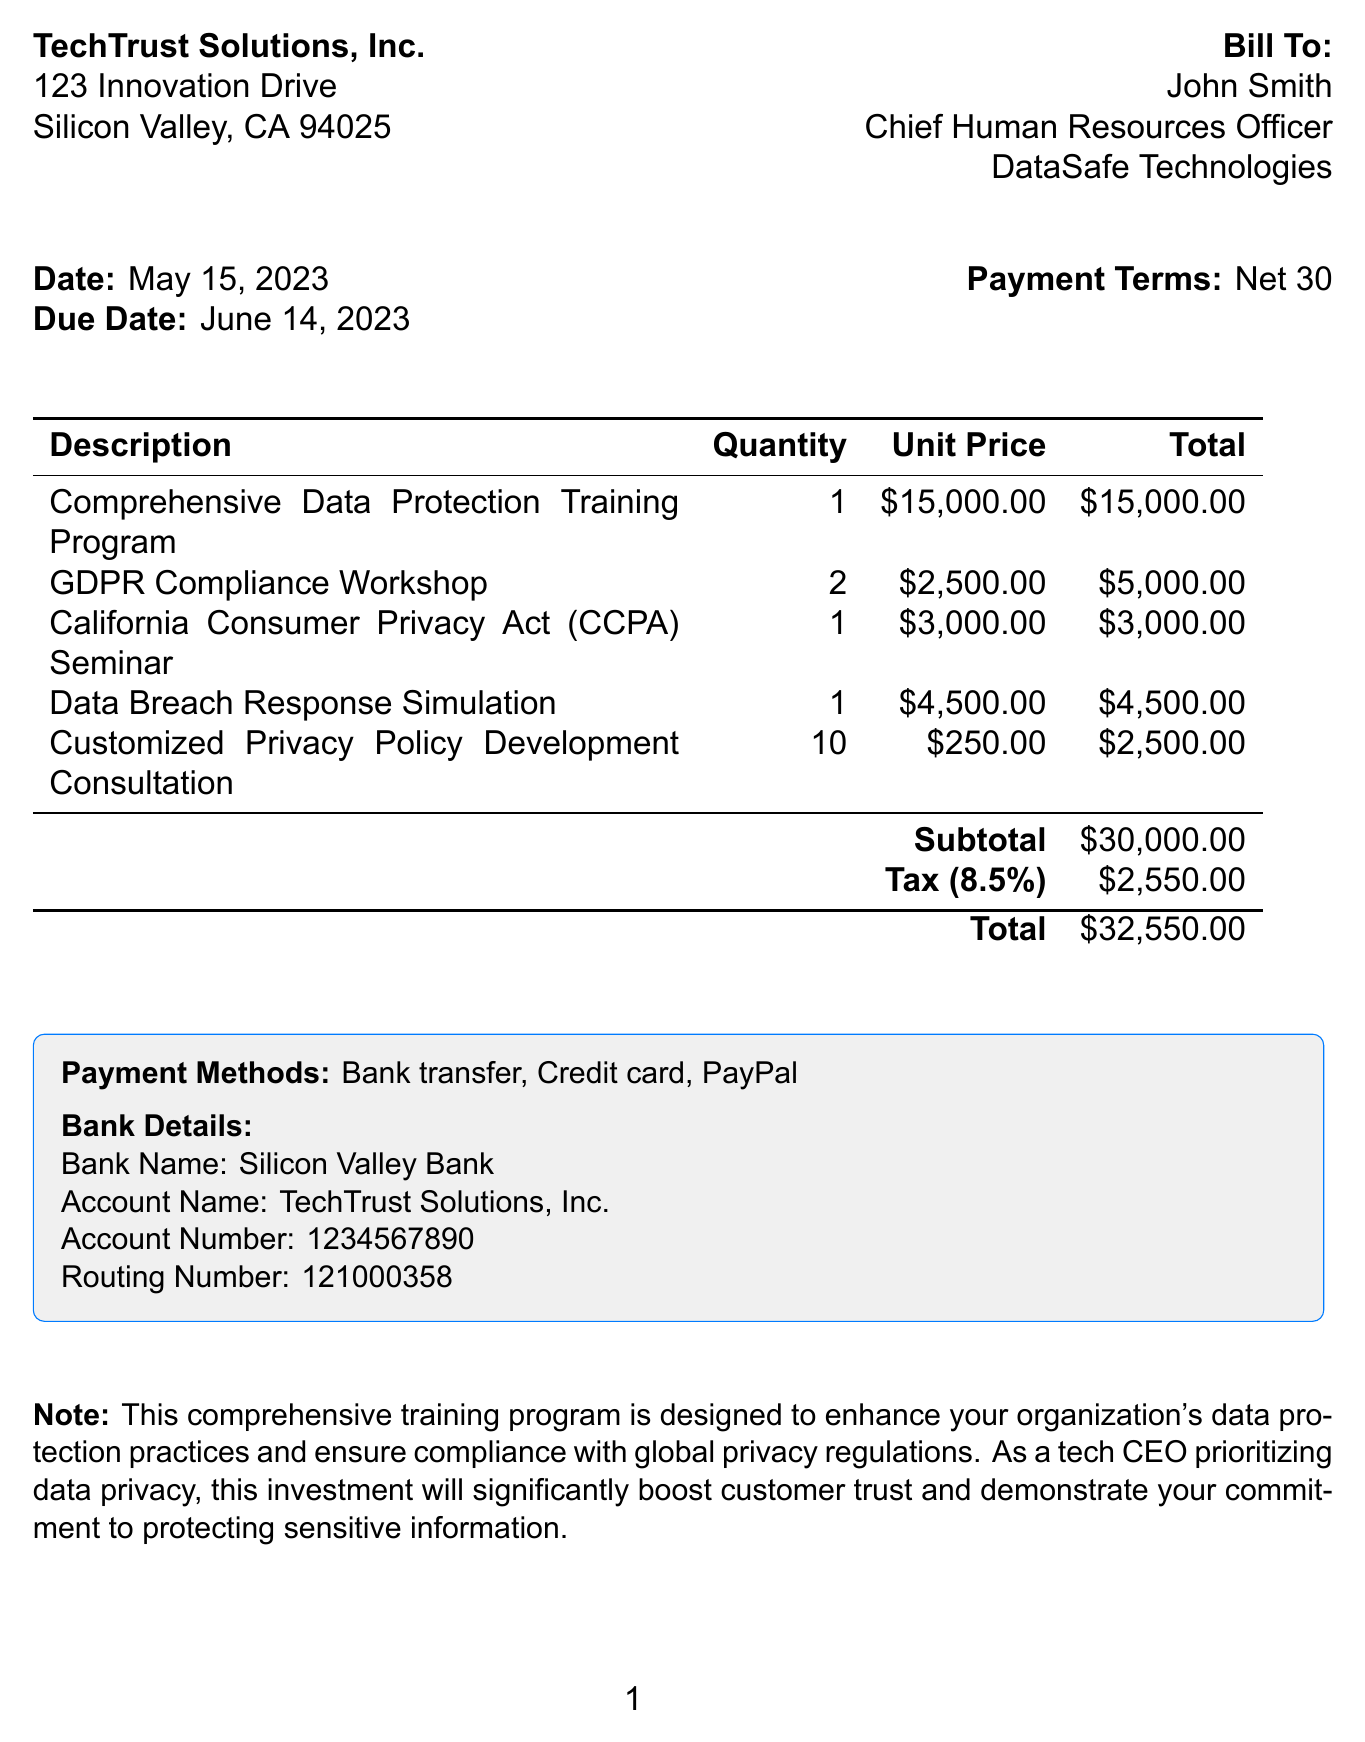What is the invoice number? The invoice number is explicitly stated at the top of the document.
Answer: INV-DP2023-001 What is the due date for this invoice? The due date is listed in the document and indicates when payment is required.
Answer: June 14, 2023 Who is the recipient of the invoice? The document specifies the name and title of the person to whom the invoice is addressed.
Answer: John Smith What is the total amount due? The total amount is calculated in the invoice and is shown towards the bottom of the document.
Answer: $32,550.00 How many GDPR Compliance Workshops are included? The quantity of this item is listed in the itemized section of the invoice.
Answer: 2 What is the tax rate applied to the invoice? The document mentions the tax rate used for calculating the tax amount.
Answer: 8.5% What is the purpose of the training program mentioned in the notes? The notes provide insight into the overall objective of the training program included in the invoice.
Answer: Enhance data protection practices How many Customized Privacy Policy Development Consultations are billed? The quantity of this service is included in the list of items provided in the invoice.
Answer: 10 What payment methods are accepted? The invoice specifies the acceptable payment methods for settling the charges.
Answer: Bank transfer, Credit card, PayPal 